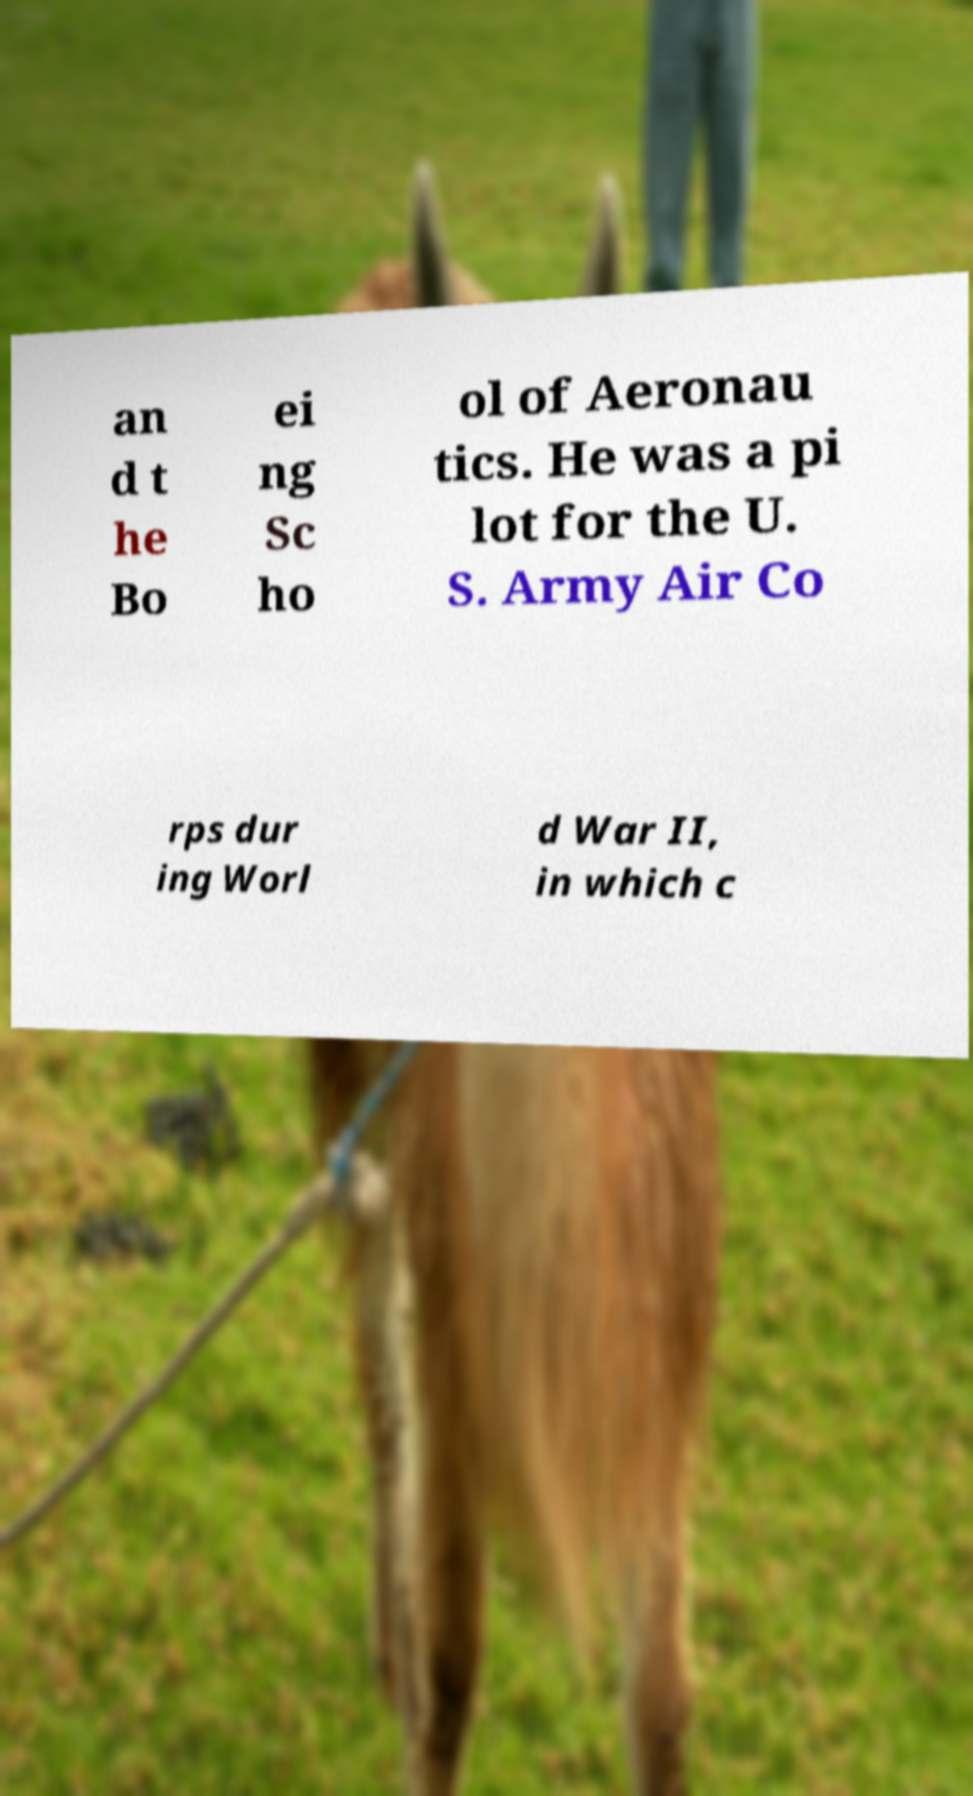Could you extract and type out the text from this image? an d t he Bo ei ng Sc ho ol of Aeronau tics. He was a pi lot for the U. S. Army Air Co rps dur ing Worl d War II, in which c 